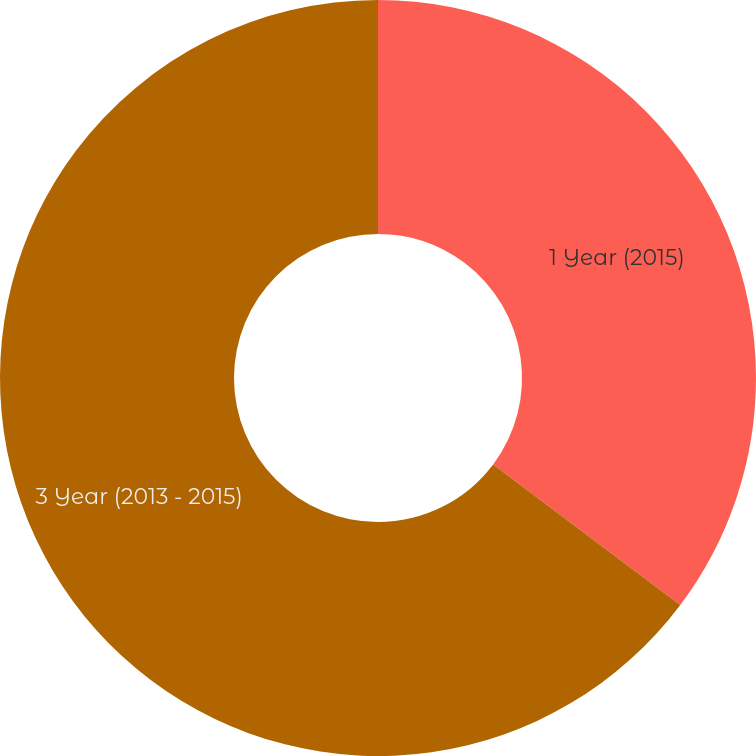Convert chart. <chart><loc_0><loc_0><loc_500><loc_500><pie_chart><fcel>1 Year (2015)<fcel>3 Year (2013 - 2015)<nl><fcel>35.25%<fcel>64.75%<nl></chart> 